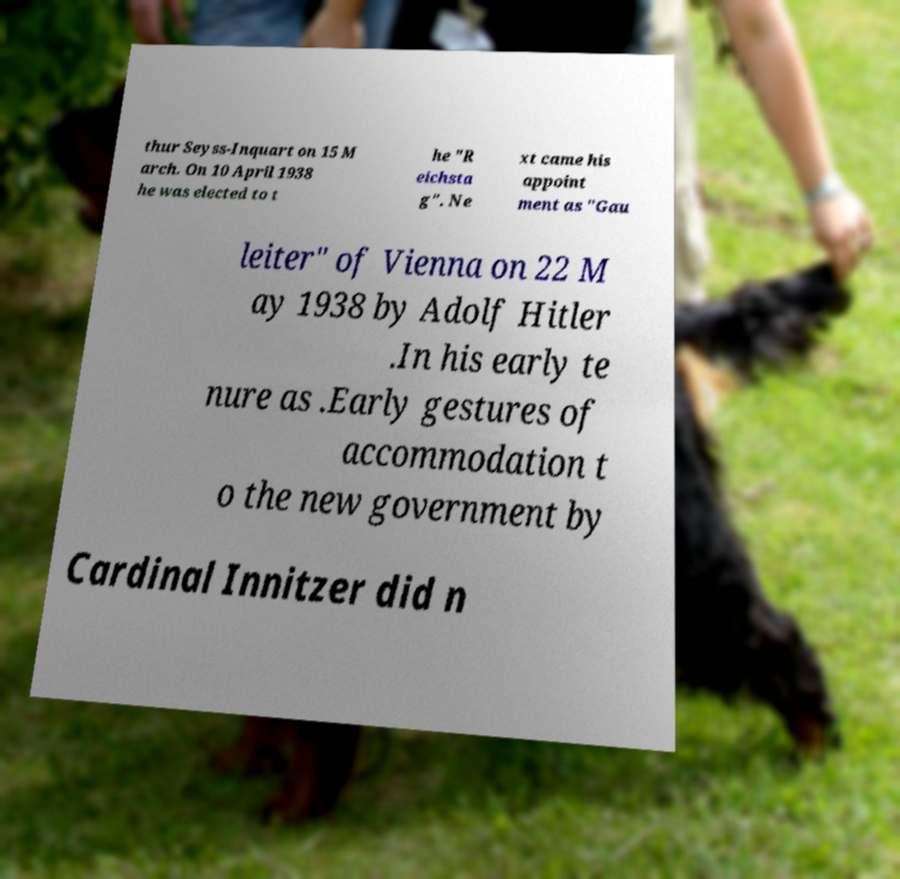Please identify and transcribe the text found in this image. thur Seyss-Inquart on 15 M arch. On 10 April 1938 he was elected to t he "R eichsta g". Ne xt came his appoint ment as "Gau leiter" of Vienna on 22 M ay 1938 by Adolf Hitler .In his early te nure as .Early gestures of accommodation t o the new government by Cardinal Innitzer did n 